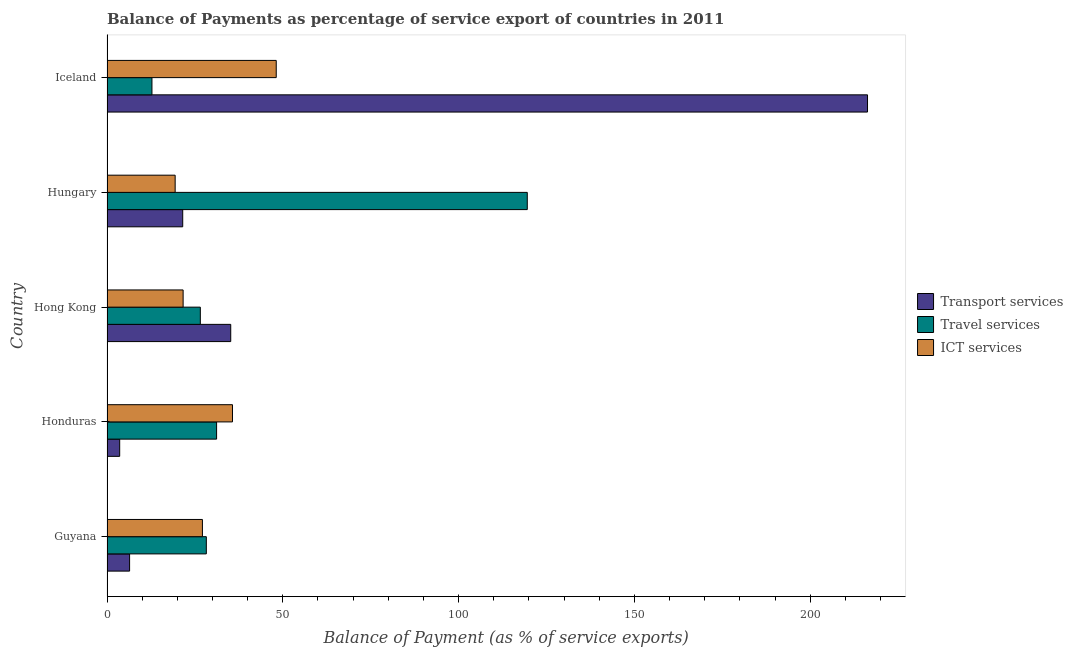How many groups of bars are there?
Your response must be concise. 5. Are the number of bars per tick equal to the number of legend labels?
Provide a succinct answer. Yes. Are the number of bars on each tick of the Y-axis equal?
Provide a succinct answer. Yes. What is the label of the 3rd group of bars from the top?
Provide a short and direct response. Hong Kong. What is the balance of payment of transport services in Honduras?
Offer a very short reply. 3.61. Across all countries, what is the maximum balance of payment of travel services?
Keep it short and to the point. 119.52. Across all countries, what is the minimum balance of payment of transport services?
Ensure brevity in your answer.  3.61. In which country was the balance of payment of ict services minimum?
Keep it short and to the point. Hungary. What is the total balance of payment of transport services in the graph?
Make the answer very short. 283.03. What is the difference between the balance of payment of travel services in Honduras and that in Hungary?
Offer a very short reply. -88.36. What is the difference between the balance of payment of ict services in Hungary and the balance of payment of transport services in Honduras?
Provide a short and direct response. 15.77. What is the average balance of payment of travel services per country?
Provide a succinct answer. 43.65. What is the difference between the balance of payment of ict services and balance of payment of travel services in Honduras?
Your response must be concise. 4.52. In how many countries, is the balance of payment of transport services greater than 40 %?
Provide a short and direct response. 1. What is the ratio of the balance of payment of travel services in Hungary to that in Iceland?
Provide a succinct answer. 9.35. Is the balance of payment of travel services in Guyana less than that in Iceland?
Your answer should be very brief. No. Is the difference between the balance of payment of travel services in Guyana and Hungary greater than the difference between the balance of payment of transport services in Guyana and Hungary?
Offer a very short reply. No. What is the difference between the highest and the second highest balance of payment of transport services?
Make the answer very short. 181.09. What is the difference between the highest and the lowest balance of payment of transport services?
Provide a succinct answer. 212.67. In how many countries, is the balance of payment of ict services greater than the average balance of payment of ict services taken over all countries?
Offer a very short reply. 2. What does the 1st bar from the top in Honduras represents?
Offer a terse response. ICT services. What does the 2nd bar from the bottom in Honduras represents?
Your answer should be very brief. Travel services. Is it the case that in every country, the sum of the balance of payment of transport services and balance of payment of travel services is greater than the balance of payment of ict services?
Offer a terse response. No. How many bars are there?
Your answer should be compact. 15. Are all the bars in the graph horizontal?
Your response must be concise. Yes. Are the values on the major ticks of X-axis written in scientific E-notation?
Ensure brevity in your answer.  No. How many legend labels are there?
Your response must be concise. 3. What is the title of the graph?
Ensure brevity in your answer.  Balance of Payments as percentage of service export of countries in 2011. Does "Natural gas sources" appear as one of the legend labels in the graph?
Offer a terse response. No. What is the label or title of the X-axis?
Offer a very short reply. Balance of Payment (as % of service exports). What is the Balance of Payment (as % of service exports) in Transport services in Guyana?
Keep it short and to the point. 6.43. What is the Balance of Payment (as % of service exports) in Travel services in Guyana?
Your response must be concise. 28.25. What is the Balance of Payment (as % of service exports) in ICT services in Guyana?
Your answer should be compact. 27.13. What is the Balance of Payment (as % of service exports) of Transport services in Honduras?
Give a very brief answer. 3.61. What is the Balance of Payment (as % of service exports) of Travel services in Honduras?
Provide a succinct answer. 31.16. What is the Balance of Payment (as % of service exports) in ICT services in Honduras?
Offer a very short reply. 35.68. What is the Balance of Payment (as % of service exports) of Transport services in Hong Kong?
Your answer should be compact. 35.19. What is the Balance of Payment (as % of service exports) in Travel services in Hong Kong?
Make the answer very short. 26.54. What is the Balance of Payment (as % of service exports) in ICT services in Hong Kong?
Give a very brief answer. 21.65. What is the Balance of Payment (as % of service exports) in Transport services in Hungary?
Ensure brevity in your answer.  21.53. What is the Balance of Payment (as % of service exports) in Travel services in Hungary?
Make the answer very short. 119.52. What is the Balance of Payment (as % of service exports) in ICT services in Hungary?
Give a very brief answer. 19.38. What is the Balance of Payment (as % of service exports) of Transport services in Iceland?
Make the answer very short. 216.28. What is the Balance of Payment (as % of service exports) of Travel services in Iceland?
Your response must be concise. 12.78. What is the Balance of Payment (as % of service exports) of ICT services in Iceland?
Make the answer very short. 48.13. Across all countries, what is the maximum Balance of Payment (as % of service exports) in Transport services?
Your response must be concise. 216.28. Across all countries, what is the maximum Balance of Payment (as % of service exports) in Travel services?
Make the answer very short. 119.52. Across all countries, what is the maximum Balance of Payment (as % of service exports) in ICT services?
Keep it short and to the point. 48.13. Across all countries, what is the minimum Balance of Payment (as % of service exports) of Transport services?
Offer a terse response. 3.61. Across all countries, what is the minimum Balance of Payment (as % of service exports) in Travel services?
Make the answer very short. 12.78. Across all countries, what is the minimum Balance of Payment (as % of service exports) in ICT services?
Make the answer very short. 19.38. What is the total Balance of Payment (as % of service exports) of Transport services in the graph?
Your answer should be compact. 283.03. What is the total Balance of Payment (as % of service exports) of Travel services in the graph?
Your answer should be very brief. 218.26. What is the total Balance of Payment (as % of service exports) of ICT services in the graph?
Ensure brevity in your answer.  151.97. What is the difference between the Balance of Payment (as % of service exports) in Transport services in Guyana and that in Honduras?
Provide a short and direct response. 2.82. What is the difference between the Balance of Payment (as % of service exports) of Travel services in Guyana and that in Honduras?
Offer a very short reply. -2.92. What is the difference between the Balance of Payment (as % of service exports) of ICT services in Guyana and that in Honduras?
Offer a terse response. -8.55. What is the difference between the Balance of Payment (as % of service exports) of Transport services in Guyana and that in Hong Kong?
Give a very brief answer. -28.76. What is the difference between the Balance of Payment (as % of service exports) in Travel services in Guyana and that in Hong Kong?
Offer a very short reply. 1.71. What is the difference between the Balance of Payment (as % of service exports) in ICT services in Guyana and that in Hong Kong?
Give a very brief answer. 5.49. What is the difference between the Balance of Payment (as % of service exports) in Transport services in Guyana and that in Hungary?
Provide a succinct answer. -15.11. What is the difference between the Balance of Payment (as % of service exports) of Travel services in Guyana and that in Hungary?
Provide a short and direct response. -91.27. What is the difference between the Balance of Payment (as % of service exports) of ICT services in Guyana and that in Hungary?
Keep it short and to the point. 7.75. What is the difference between the Balance of Payment (as % of service exports) in Transport services in Guyana and that in Iceland?
Make the answer very short. -209.85. What is the difference between the Balance of Payment (as % of service exports) in Travel services in Guyana and that in Iceland?
Make the answer very short. 15.47. What is the difference between the Balance of Payment (as % of service exports) in ICT services in Guyana and that in Iceland?
Make the answer very short. -21. What is the difference between the Balance of Payment (as % of service exports) in Transport services in Honduras and that in Hong Kong?
Provide a succinct answer. -31.58. What is the difference between the Balance of Payment (as % of service exports) of Travel services in Honduras and that in Hong Kong?
Offer a terse response. 4.62. What is the difference between the Balance of Payment (as % of service exports) in ICT services in Honduras and that in Hong Kong?
Ensure brevity in your answer.  14.04. What is the difference between the Balance of Payment (as % of service exports) in Transport services in Honduras and that in Hungary?
Offer a very short reply. -17.92. What is the difference between the Balance of Payment (as % of service exports) of Travel services in Honduras and that in Hungary?
Provide a succinct answer. -88.36. What is the difference between the Balance of Payment (as % of service exports) in ICT services in Honduras and that in Hungary?
Make the answer very short. 16.3. What is the difference between the Balance of Payment (as % of service exports) in Transport services in Honduras and that in Iceland?
Keep it short and to the point. -212.67. What is the difference between the Balance of Payment (as % of service exports) in Travel services in Honduras and that in Iceland?
Offer a terse response. 18.38. What is the difference between the Balance of Payment (as % of service exports) of ICT services in Honduras and that in Iceland?
Give a very brief answer. -12.44. What is the difference between the Balance of Payment (as % of service exports) in Transport services in Hong Kong and that in Hungary?
Offer a very short reply. 13.65. What is the difference between the Balance of Payment (as % of service exports) in Travel services in Hong Kong and that in Hungary?
Ensure brevity in your answer.  -92.98. What is the difference between the Balance of Payment (as % of service exports) in ICT services in Hong Kong and that in Hungary?
Your response must be concise. 2.27. What is the difference between the Balance of Payment (as % of service exports) in Transport services in Hong Kong and that in Iceland?
Your answer should be compact. -181.09. What is the difference between the Balance of Payment (as % of service exports) in Travel services in Hong Kong and that in Iceland?
Keep it short and to the point. 13.76. What is the difference between the Balance of Payment (as % of service exports) in ICT services in Hong Kong and that in Iceland?
Provide a short and direct response. -26.48. What is the difference between the Balance of Payment (as % of service exports) in Transport services in Hungary and that in Iceland?
Offer a very short reply. -194.75. What is the difference between the Balance of Payment (as % of service exports) in Travel services in Hungary and that in Iceland?
Your answer should be very brief. 106.74. What is the difference between the Balance of Payment (as % of service exports) in ICT services in Hungary and that in Iceland?
Your answer should be very brief. -28.75. What is the difference between the Balance of Payment (as % of service exports) of Transport services in Guyana and the Balance of Payment (as % of service exports) of Travel services in Honduras?
Keep it short and to the point. -24.74. What is the difference between the Balance of Payment (as % of service exports) of Transport services in Guyana and the Balance of Payment (as % of service exports) of ICT services in Honduras?
Give a very brief answer. -29.26. What is the difference between the Balance of Payment (as % of service exports) in Travel services in Guyana and the Balance of Payment (as % of service exports) in ICT services in Honduras?
Ensure brevity in your answer.  -7.44. What is the difference between the Balance of Payment (as % of service exports) of Transport services in Guyana and the Balance of Payment (as % of service exports) of Travel services in Hong Kong?
Your answer should be compact. -20.11. What is the difference between the Balance of Payment (as % of service exports) of Transport services in Guyana and the Balance of Payment (as % of service exports) of ICT services in Hong Kong?
Ensure brevity in your answer.  -15.22. What is the difference between the Balance of Payment (as % of service exports) of Travel services in Guyana and the Balance of Payment (as % of service exports) of ICT services in Hong Kong?
Offer a terse response. 6.6. What is the difference between the Balance of Payment (as % of service exports) in Transport services in Guyana and the Balance of Payment (as % of service exports) in Travel services in Hungary?
Offer a very short reply. -113.1. What is the difference between the Balance of Payment (as % of service exports) of Transport services in Guyana and the Balance of Payment (as % of service exports) of ICT services in Hungary?
Your answer should be compact. -12.95. What is the difference between the Balance of Payment (as % of service exports) in Travel services in Guyana and the Balance of Payment (as % of service exports) in ICT services in Hungary?
Your response must be concise. 8.87. What is the difference between the Balance of Payment (as % of service exports) in Transport services in Guyana and the Balance of Payment (as % of service exports) in Travel services in Iceland?
Offer a terse response. -6.36. What is the difference between the Balance of Payment (as % of service exports) in Transport services in Guyana and the Balance of Payment (as % of service exports) in ICT services in Iceland?
Give a very brief answer. -41.7. What is the difference between the Balance of Payment (as % of service exports) of Travel services in Guyana and the Balance of Payment (as % of service exports) of ICT services in Iceland?
Make the answer very short. -19.88. What is the difference between the Balance of Payment (as % of service exports) of Transport services in Honduras and the Balance of Payment (as % of service exports) of Travel services in Hong Kong?
Provide a short and direct response. -22.93. What is the difference between the Balance of Payment (as % of service exports) in Transport services in Honduras and the Balance of Payment (as % of service exports) in ICT services in Hong Kong?
Offer a terse response. -18.04. What is the difference between the Balance of Payment (as % of service exports) of Travel services in Honduras and the Balance of Payment (as % of service exports) of ICT services in Hong Kong?
Your answer should be compact. 9.52. What is the difference between the Balance of Payment (as % of service exports) in Transport services in Honduras and the Balance of Payment (as % of service exports) in Travel services in Hungary?
Ensure brevity in your answer.  -115.91. What is the difference between the Balance of Payment (as % of service exports) of Transport services in Honduras and the Balance of Payment (as % of service exports) of ICT services in Hungary?
Give a very brief answer. -15.77. What is the difference between the Balance of Payment (as % of service exports) of Travel services in Honduras and the Balance of Payment (as % of service exports) of ICT services in Hungary?
Your answer should be compact. 11.78. What is the difference between the Balance of Payment (as % of service exports) of Transport services in Honduras and the Balance of Payment (as % of service exports) of Travel services in Iceland?
Provide a succinct answer. -9.17. What is the difference between the Balance of Payment (as % of service exports) in Transport services in Honduras and the Balance of Payment (as % of service exports) in ICT services in Iceland?
Provide a short and direct response. -44.52. What is the difference between the Balance of Payment (as % of service exports) in Travel services in Honduras and the Balance of Payment (as % of service exports) in ICT services in Iceland?
Your response must be concise. -16.96. What is the difference between the Balance of Payment (as % of service exports) in Transport services in Hong Kong and the Balance of Payment (as % of service exports) in Travel services in Hungary?
Offer a terse response. -84.33. What is the difference between the Balance of Payment (as % of service exports) of Transport services in Hong Kong and the Balance of Payment (as % of service exports) of ICT services in Hungary?
Keep it short and to the point. 15.81. What is the difference between the Balance of Payment (as % of service exports) in Travel services in Hong Kong and the Balance of Payment (as % of service exports) in ICT services in Hungary?
Give a very brief answer. 7.16. What is the difference between the Balance of Payment (as % of service exports) of Transport services in Hong Kong and the Balance of Payment (as % of service exports) of Travel services in Iceland?
Provide a succinct answer. 22.4. What is the difference between the Balance of Payment (as % of service exports) of Transport services in Hong Kong and the Balance of Payment (as % of service exports) of ICT services in Iceland?
Make the answer very short. -12.94. What is the difference between the Balance of Payment (as % of service exports) in Travel services in Hong Kong and the Balance of Payment (as % of service exports) in ICT services in Iceland?
Provide a succinct answer. -21.59. What is the difference between the Balance of Payment (as % of service exports) in Transport services in Hungary and the Balance of Payment (as % of service exports) in Travel services in Iceland?
Keep it short and to the point. 8.75. What is the difference between the Balance of Payment (as % of service exports) of Transport services in Hungary and the Balance of Payment (as % of service exports) of ICT services in Iceland?
Make the answer very short. -26.6. What is the difference between the Balance of Payment (as % of service exports) in Travel services in Hungary and the Balance of Payment (as % of service exports) in ICT services in Iceland?
Give a very brief answer. 71.39. What is the average Balance of Payment (as % of service exports) in Transport services per country?
Your response must be concise. 56.61. What is the average Balance of Payment (as % of service exports) of Travel services per country?
Your answer should be compact. 43.65. What is the average Balance of Payment (as % of service exports) of ICT services per country?
Your answer should be compact. 30.39. What is the difference between the Balance of Payment (as % of service exports) of Transport services and Balance of Payment (as % of service exports) of Travel services in Guyana?
Give a very brief answer. -21.82. What is the difference between the Balance of Payment (as % of service exports) of Transport services and Balance of Payment (as % of service exports) of ICT services in Guyana?
Provide a short and direct response. -20.71. What is the difference between the Balance of Payment (as % of service exports) in Travel services and Balance of Payment (as % of service exports) in ICT services in Guyana?
Ensure brevity in your answer.  1.11. What is the difference between the Balance of Payment (as % of service exports) in Transport services and Balance of Payment (as % of service exports) in Travel services in Honduras?
Provide a short and direct response. -27.56. What is the difference between the Balance of Payment (as % of service exports) of Transport services and Balance of Payment (as % of service exports) of ICT services in Honduras?
Give a very brief answer. -32.08. What is the difference between the Balance of Payment (as % of service exports) of Travel services and Balance of Payment (as % of service exports) of ICT services in Honduras?
Provide a short and direct response. -4.52. What is the difference between the Balance of Payment (as % of service exports) of Transport services and Balance of Payment (as % of service exports) of Travel services in Hong Kong?
Your answer should be very brief. 8.65. What is the difference between the Balance of Payment (as % of service exports) in Transport services and Balance of Payment (as % of service exports) in ICT services in Hong Kong?
Give a very brief answer. 13.54. What is the difference between the Balance of Payment (as % of service exports) in Travel services and Balance of Payment (as % of service exports) in ICT services in Hong Kong?
Offer a terse response. 4.89. What is the difference between the Balance of Payment (as % of service exports) in Transport services and Balance of Payment (as % of service exports) in Travel services in Hungary?
Offer a terse response. -97.99. What is the difference between the Balance of Payment (as % of service exports) in Transport services and Balance of Payment (as % of service exports) in ICT services in Hungary?
Provide a short and direct response. 2.15. What is the difference between the Balance of Payment (as % of service exports) in Travel services and Balance of Payment (as % of service exports) in ICT services in Hungary?
Provide a succinct answer. 100.14. What is the difference between the Balance of Payment (as % of service exports) of Transport services and Balance of Payment (as % of service exports) of Travel services in Iceland?
Provide a succinct answer. 203.5. What is the difference between the Balance of Payment (as % of service exports) of Transport services and Balance of Payment (as % of service exports) of ICT services in Iceland?
Your answer should be very brief. 168.15. What is the difference between the Balance of Payment (as % of service exports) in Travel services and Balance of Payment (as % of service exports) in ICT services in Iceland?
Your response must be concise. -35.35. What is the ratio of the Balance of Payment (as % of service exports) of Transport services in Guyana to that in Honduras?
Your answer should be compact. 1.78. What is the ratio of the Balance of Payment (as % of service exports) in Travel services in Guyana to that in Honduras?
Offer a terse response. 0.91. What is the ratio of the Balance of Payment (as % of service exports) in ICT services in Guyana to that in Honduras?
Your answer should be compact. 0.76. What is the ratio of the Balance of Payment (as % of service exports) in Transport services in Guyana to that in Hong Kong?
Your answer should be very brief. 0.18. What is the ratio of the Balance of Payment (as % of service exports) in Travel services in Guyana to that in Hong Kong?
Make the answer very short. 1.06. What is the ratio of the Balance of Payment (as % of service exports) of ICT services in Guyana to that in Hong Kong?
Your response must be concise. 1.25. What is the ratio of the Balance of Payment (as % of service exports) of Transport services in Guyana to that in Hungary?
Offer a terse response. 0.3. What is the ratio of the Balance of Payment (as % of service exports) in Travel services in Guyana to that in Hungary?
Your answer should be very brief. 0.24. What is the ratio of the Balance of Payment (as % of service exports) of ICT services in Guyana to that in Hungary?
Keep it short and to the point. 1.4. What is the ratio of the Balance of Payment (as % of service exports) of Transport services in Guyana to that in Iceland?
Your response must be concise. 0.03. What is the ratio of the Balance of Payment (as % of service exports) in Travel services in Guyana to that in Iceland?
Ensure brevity in your answer.  2.21. What is the ratio of the Balance of Payment (as % of service exports) of ICT services in Guyana to that in Iceland?
Make the answer very short. 0.56. What is the ratio of the Balance of Payment (as % of service exports) of Transport services in Honduras to that in Hong Kong?
Your response must be concise. 0.1. What is the ratio of the Balance of Payment (as % of service exports) in Travel services in Honduras to that in Hong Kong?
Ensure brevity in your answer.  1.17. What is the ratio of the Balance of Payment (as % of service exports) in ICT services in Honduras to that in Hong Kong?
Offer a very short reply. 1.65. What is the ratio of the Balance of Payment (as % of service exports) in Transport services in Honduras to that in Hungary?
Give a very brief answer. 0.17. What is the ratio of the Balance of Payment (as % of service exports) in Travel services in Honduras to that in Hungary?
Provide a short and direct response. 0.26. What is the ratio of the Balance of Payment (as % of service exports) of ICT services in Honduras to that in Hungary?
Your response must be concise. 1.84. What is the ratio of the Balance of Payment (as % of service exports) in Transport services in Honduras to that in Iceland?
Keep it short and to the point. 0.02. What is the ratio of the Balance of Payment (as % of service exports) of Travel services in Honduras to that in Iceland?
Offer a terse response. 2.44. What is the ratio of the Balance of Payment (as % of service exports) of ICT services in Honduras to that in Iceland?
Your answer should be very brief. 0.74. What is the ratio of the Balance of Payment (as % of service exports) in Transport services in Hong Kong to that in Hungary?
Your response must be concise. 1.63. What is the ratio of the Balance of Payment (as % of service exports) in Travel services in Hong Kong to that in Hungary?
Provide a succinct answer. 0.22. What is the ratio of the Balance of Payment (as % of service exports) in ICT services in Hong Kong to that in Hungary?
Offer a very short reply. 1.12. What is the ratio of the Balance of Payment (as % of service exports) in Transport services in Hong Kong to that in Iceland?
Your answer should be very brief. 0.16. What is the ratio of the Balance of Payment (as % of service exports) in Travel services in Hong Kong to that in Iceland?
Provide a short and direct response. 2.08. What is the ratio of the Balance of Payment (as % of service exports) in ICT services in Hong Kong to that in Iceland?
Provide a succinct answer. 0.45. What is the ratio of the Balance of Payment (as % of service exports) of Transport services in Hungary to that in Iceland?
Make the answer very short. 0.1. What is the ratio of the Balance of Payment (as % of service exports) of Travel services in Hungary to that in Iceland?
Keep it short and to the point. 9.35. What is the ratio of the Balance of Payment (as % of service exports) in ICT services in Hungary to that in Iceland?
Keep it short and to the point. 0.4. What is the difference between the highest and the second highest Balance of Payment (as % of service exports) in Transport services?
Keep it short and to the point. 181.09. What is the difference between the highest and the second highest Balance of Payment (as % of service exports) in Travel services?
Offer a very short reply. 88.36. What is the difference between the highest and the second highest Balance of Payment (as % of service exports) of ICT services?
Make the answer very short. 12.44. What is the difference between the highest and the lowest Balance of Payment (as % of service exports) in Transport services?
Offer a terse response. 212.67. What is the difference between the highest and the lowest Balance of Payment (as % of service exports) of Travel services?
Ensure brevity in your answer.  106.74. What is the difference between the highest and the lowest Balance of Payment (as % of service exports) of ICT services?
Offer a terse response. 28.75. 